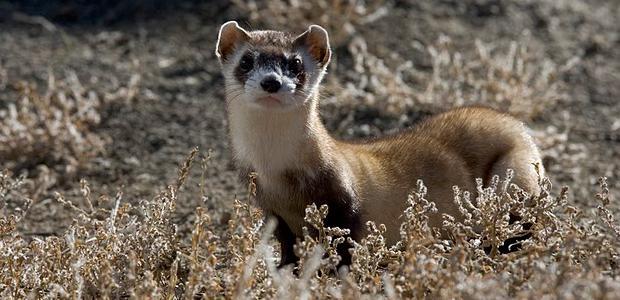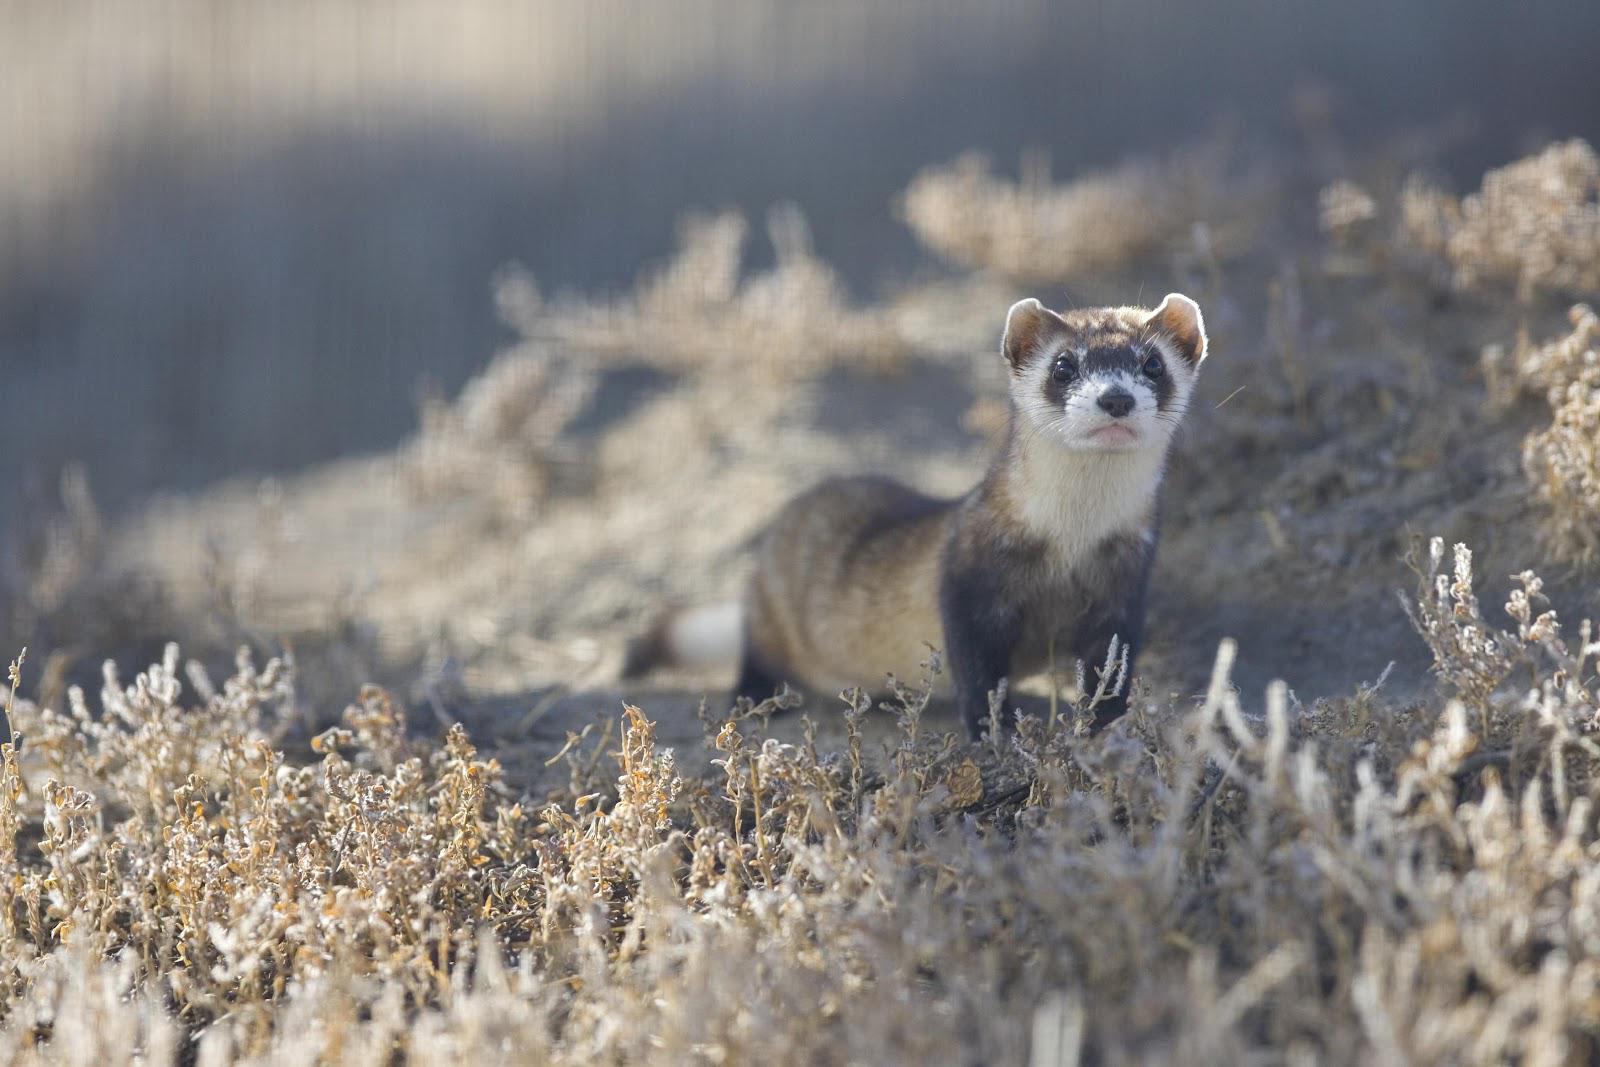The first image is the image on the left, the second image is the image on the right. Examine the images to the left and right. Is the description "There are exactly two animals and one is emerging from a hole in the dirt." accurate? Answer yes or no. No. The first image is the image on the left, the second image is the image on the right. Evaluate the accuracy of this statement regarding the images: "The Muscatel is partly viable as they come out of the dirt hole in the ground.". Is it true? Answer yes or no. No. 